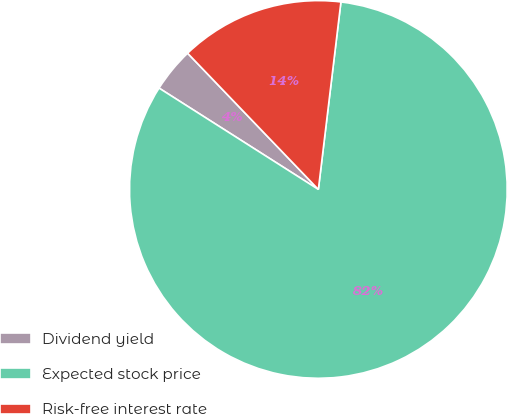<chart> <loc_0><loc_0><loc_500><loc_500><pie_chart><fcel>Dividend yield<fcel>Expected stock price<fcel>Risk-free interest rate<nl><fcel>3.81%<fcel>82.11%<fcel>14.08%<nl></chart> 